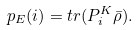Convert formula to latex. <formula><loc_0><loc_0><loc_500><loc_500>p _ { E } ( i ) = t r ( P _ { i } ^ { K } \bar { \rho } ) .</formula> 